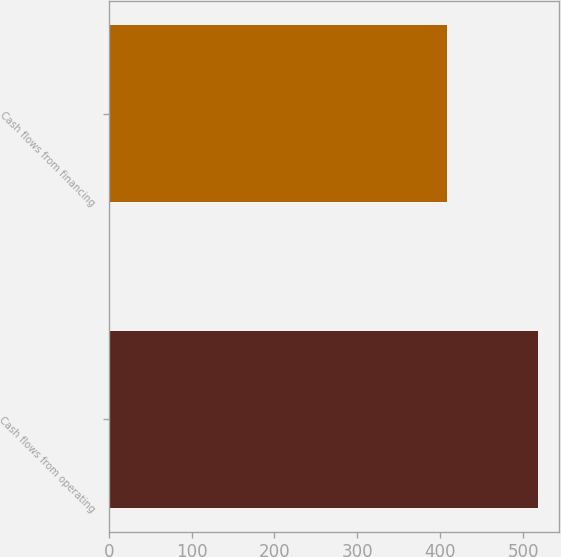Convert chart. <chart><loc_0><loc_0><loc_500><loc_500><bar_chart><fcel>Cash flows from operating<fcel>Cash flows from financing<nl><fcel>517.6<fcel>408.6<nl></chart> 